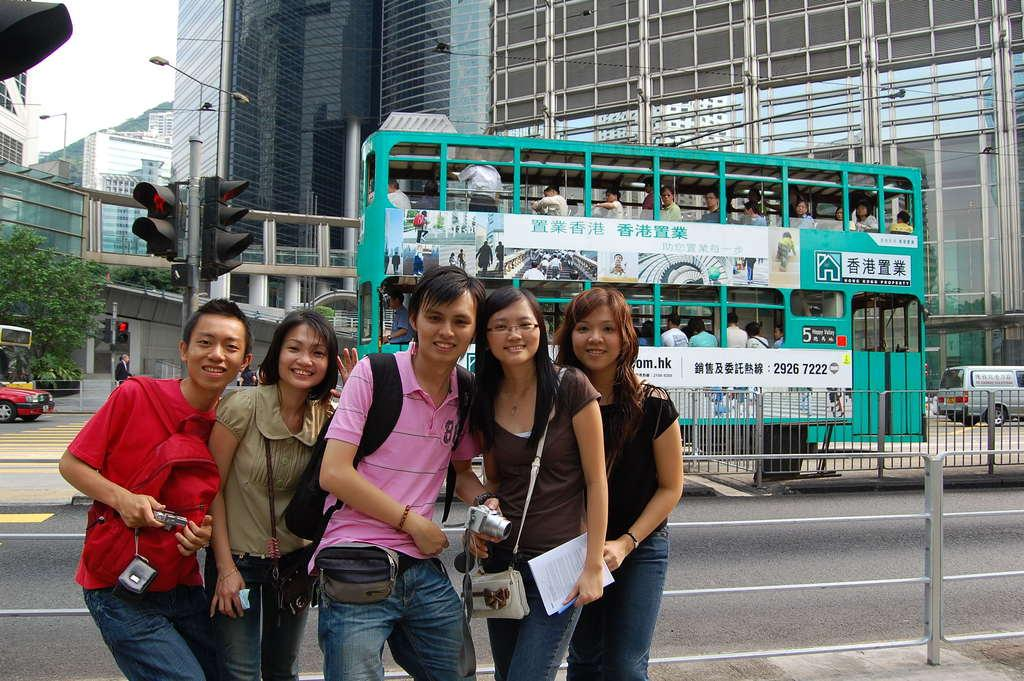<image>
Give a short and clear explanation of the subsequent image. Turqouise bus with the numbers "29267222" right behind a group of people taking a picture. 